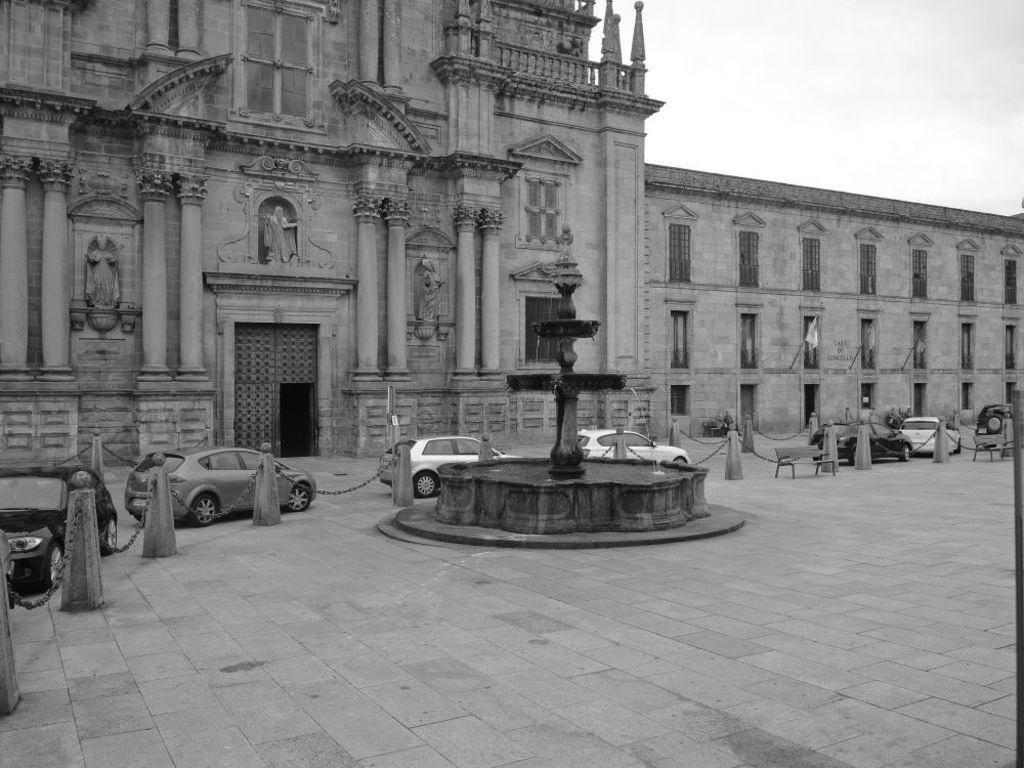Can you describe this image briefly? In the image in the center, we can see few vehicles. And we can see the poles, benches and one fountain. In the background, we can see the sky, clouds, windows, sculptures and one building. 